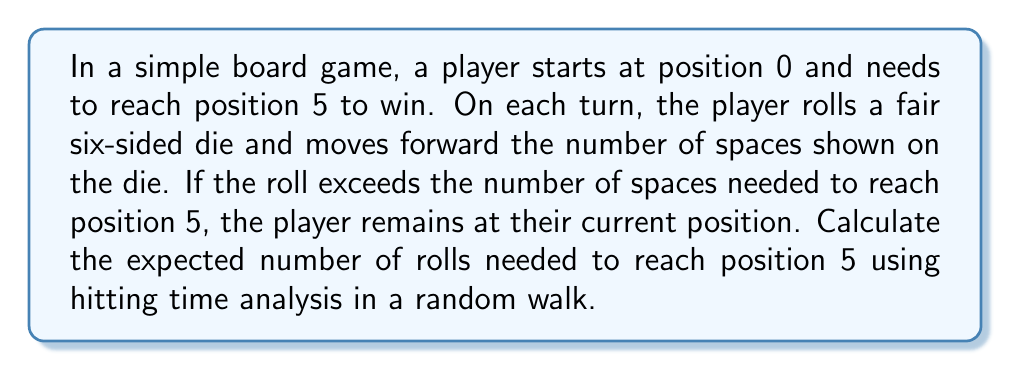Show me your answer to this math problem. Let's approach this step-by-step using hitting time analysis:

1) Let $E_i$ be the expected number of rolls to reach position 5 starting from position $i$.

2) We need to find $E_0$.

3) For $i = 0, 1, 2, 3, 4$, we can write:

   $$E_i = 1 + \frac{1}{6}(E_{i+1} + E_{i+2} + E_{i+3} + E_{i+4} + E_{i+5} + E_i)$$

   This is because we always roll once (the 1), and then with equal probability (1/6) we move to any of the next 5 positions or stay where we are.

4) For $i = 5$, we have $E_5 = 0$ as we've reached the goal.

5) Simplifying the equation in step 3:

   $$6E_i = 6 + E_{i+1} + E_{i+2} + E_{i+3} + E_{i+4} + E_{i+5} + E_i$$
   $$5E_i = 6 + E_{i+1} + E_{i+2} + E_{i+3} + E_{i+4} + E_{i+5}$$

6) This gives us a system of equations:

   $$5E_4 = 6 + E_5 = 6$$
   $$5E_3 = 6 + E_4 + E_5 = 6 + E_4$$
   $$5E_2 = 6 + E_3 + E_4 + E_5 = 6 + E_3 + E_4$$
   $$5E_1 = 6 + E_2 + E_3 + E_4 + E_5 = 6 + E_2 + E_3 + E_4$$
   $$5E_0 = 6 + E_1 + E_2 + E_3 + E_4 + E_5 = 6 + E_1 + E_2 + E_3 + E_4$$

7) Solving this system of equations from bottom to top:

   $$E_4 = \frac{6}{5} = 1.2$$
   $$E_3 = \frac{6 + 1.2}{5} = 1.44$$
   $$E_2 = \frac{6 + 1.44 + 1.2}{5} = 1.728$$
   $$E_1 = \frac{6 + 1.728 + 1.44 + 1.2}{5} = 2.0736$$
   $$E_0 = \frac{6 + 2.0736 + 1.728 + 1.44 + 1.2}{5} = 2.48832$$

Therefore, the expected number of rolls to reach position 5 starting from position 0 is 2.48832.
Answer: $2.48832$ rolls 